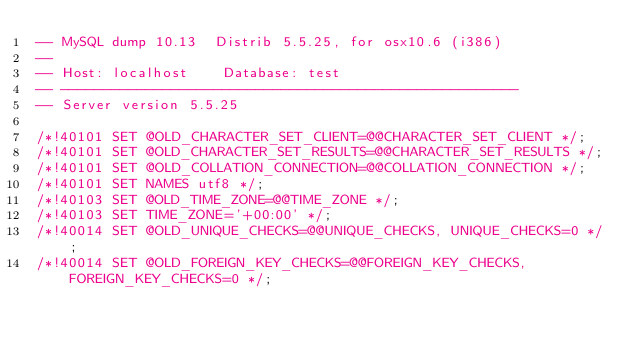Convert code to text. <code><loc_0><loc_0><loc_500><loc_500><_SQL_>-- MySQL dump 10.13  Distrib 5.5.25, for osx10.6 (i386)
--
-- Host: localhost    Database: test
-- ------------------------------------------------------
-- Server version	5.5.25

/*!40101 SET @OLD_CHARACTER_SET_CLIENT=@@CHARACTER_SET_CLIENT */;
/*!40101 SET @OLD_CHARACTER_SET_RESULTS=@@CHARACTER_SET_RESULTS */;
/*!40101 SET @OLD_COLLATION_CONNECTION=@@COLLATION_CONNECTION */;
/*!40101 SET NAMES utf8 */;
/*!40103 SET @OLD_TIME_ZONE=@@TIME_ZONE */;
/*!40103 SET TIME_ZONE='+00:00' */;
/*!40014 SET @OLD_UNIQUE_CHECKS=@@UNIQUE_CHECKS, UNIQUE_CHECKS=0 */;
/*!40014 SET @OLD_FOREIGN_KEY_CHECKS=@@FOREIGN_KEY_CHECKS, FOREIGN_KEY_CHECKS=0 */;</code> 